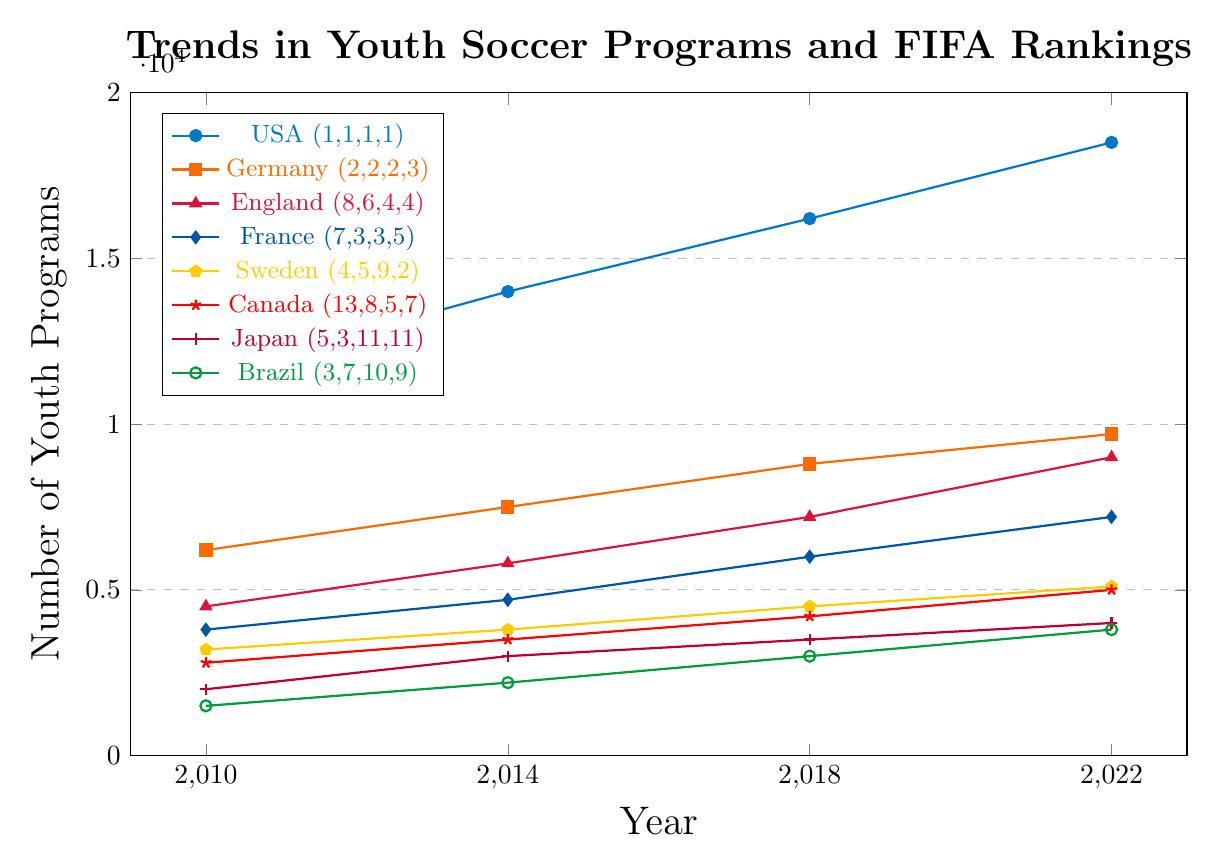Which country had the largest number of youth soccer programs in 2022? By visually inspecting the height of the lines at the year 2022, the USA has the highest point among all the countries.
Answer: USA Which country had the highest improvement in youth soccer programs from 2010 to 2022? The USA increased from 11500 in 2010 to 18500 in 2022, an increase of 7000, while other countries had smaller increases.
Answer: USA Did any country experience a significant drop in FIFA ranking despite an increase in youth soccer programs? Sweden increased its youth programs from 2010 to 2022 but saw its FIFA ranking drop from 4 to 9 from 2010 to 2018 before improving again to 2 by 2022.
Answer: Sweden How did Japan's youth soccer programs and FIFA ranking change from 2010 to 2022? Japan's youth programs increased from 2000 in 2010 to 4000 in 2022, while its FIFA ranking fluctuated, worsening from 5 in 2010 to 11 in 2022.
Answer: Youth programs increased, ranking worsened Compare the trends in youth soccer programs for Germany and England from 2010 to 2022 in terms of growth rate. Germany's programs grew from 6200 to 9700 and England's from 4500 to 9000. Germany's total growth is 3500 while England's is 4500, indicating that both increased, but England had a higher growth rate.
Answer: England had a higher growth rate Which country had the steadiest improvement in FIFA ranking paired with an increase in youth soccer programs? The USA consistently maintained its FIFA rank of 1 while increasing its youth programs steadily over the years from 11500 to 18500.
Answer: USA Between 2010 and 2022, which country saw the smallest increase in youth soccer programs? Brazil saw the smallest increase in youth programs from 1500 in 2010 to 3800 in 2022, a net increase of 2300.
Answer: Brazil Did any country's youth soccer program growth correlate poorly with its FIFA ranking improvement? Japan's youth programs grew from 2000 in 2010 to 4000 in 2022, but its FIFA ranking declined from 5 to 11, showing a negative correlation.
Answer: Japan 